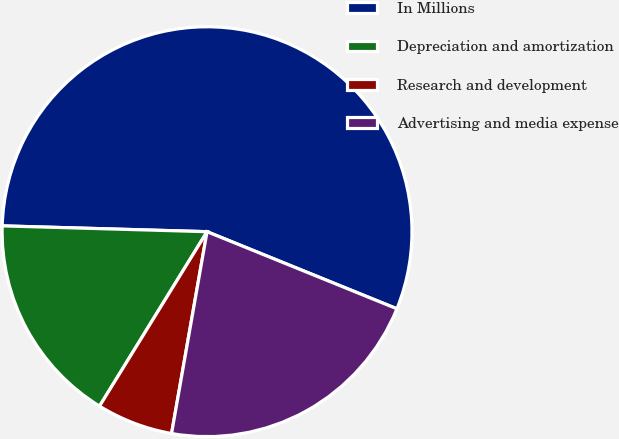Convert chart to OTSL. <chart><loc_0><loc_0><loc_500><loc_500><pie_chart><fcel>In Millions<fcel>Depreciation and amortization<fcel>Research and development<fcel>Advertising and media expense<nl><fcel>55.68%<fcel>16.66%<fcel>6.02%<fcel>21.63%<nl></chart> 